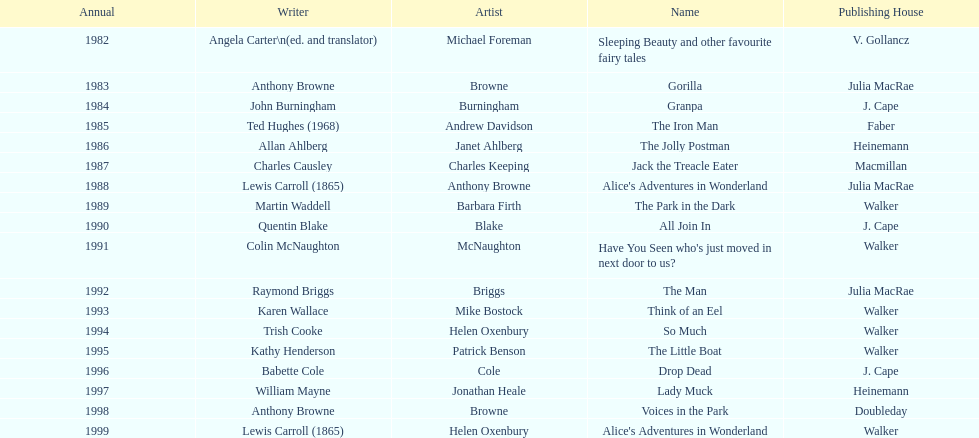Parse the full table. {'header': ['Annual', 'Writer', 'Artist', 'Name', 'Publishing House'], 'rows': [['1982', 'Angela Carter\\n(ed. and translator)', 'Michael Foreman', 'Sleeping Beauty and other favourite fairy tales', 'V. Gollancz'], ['1983', 'Anthony Browne', 'Browne', 'Gorilla', 'Julia MacRae'], ['1984', 'John Burningham', 'Burningham', 'Granpa', 'J. Cape'], ['1985', 'Ted Hughes (1968)', 'Andrew Davidson', 'The Iron Man', 'Faber'], ['1986', 'Allan Ahlberg', 'Janet Ahlberg', 'The Jolly Postman', 'Heinemann'], ['1987', 'Charles Causley', 'Charles Keeping', 'Jack the Treacle Eater', 'Macmillan'], ['1988', 'Lewis Carroll (1865)', 'Anthony Browne', "Alice's Adventures in Wonderland", 'Julia MacRae'], ['1989', 'Martin Waddell', 'Barbara Firth', 'The Park in the Dark', 'Walker'], ['1990', 'Quentin Blake', 'Blake', 'All Join In', 'J. Cape'], ['1991', 'Colin McNaughton', 'McNaughton', "Have You Seen who's just moved in next door to us?", 'Walker'], ['1992', 'Raymond Briggs', 'Briggs', 'The Man', 'Julia MacRae'], ['1993', 'Karen Wallace', 'Mike Bostock', 'Think of an Eel', 'Walker'], ['1994', 'Trish Cooke', 'Helen Oxenbury', 'So Much', 'Walker'], ['1995', 'Kathy Henderson', 'Patrick Benson', 'The Little Boat', 'Walker'], ['1996', 'Babette Cole', 'Cole', 'Drop Dead', 'J. Cape'], ['1997', 'William Mayne', 'Jonathan Heale', 'Lady Muck', 'Heinemann'], ['1998', 'Anthony Browne', 'Browne', 'Voices in the Park', 'Doubleday'], ['1999', 'Lewis Carroll (1865)', 'Helen Oxenbury', "Alice's Adventures in Wonderland", 'Walker']]} How many times has anthony browne won an kurt maschler award for illustration? 3. 